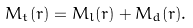<formula> <loc_0><loc_0><loc_500><loc_500>M _ { t } ( r ) = M _ { l } ( r ) + M _ { d } ( r ) .</formula> 